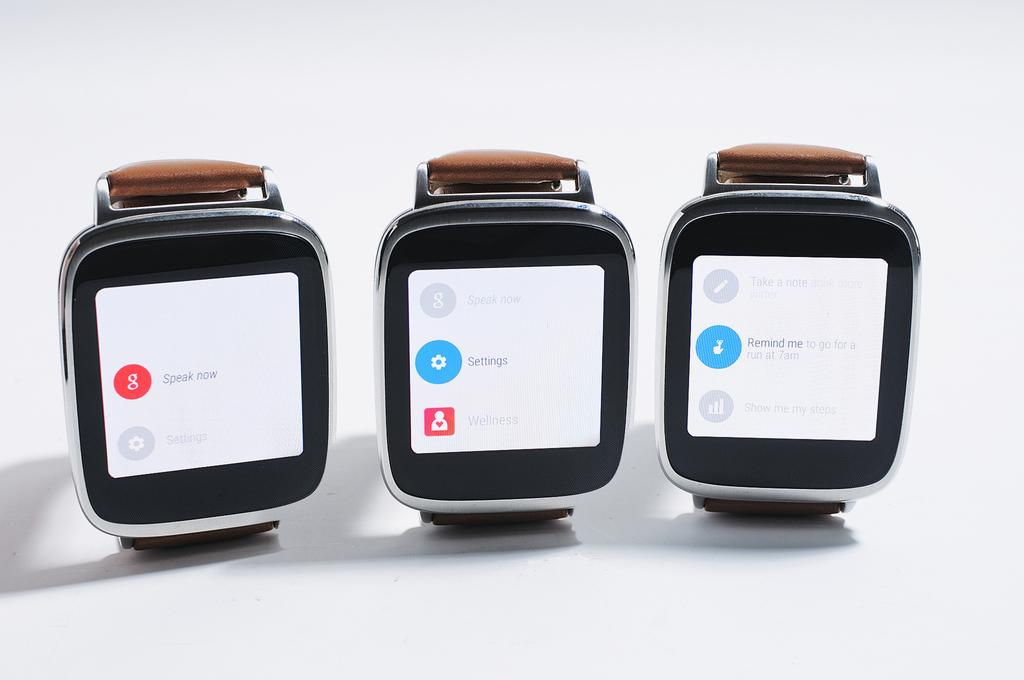<image>
Present a compact description of the photo's key features. Three smart watches with dialogues on the screens such as one to speak now. 